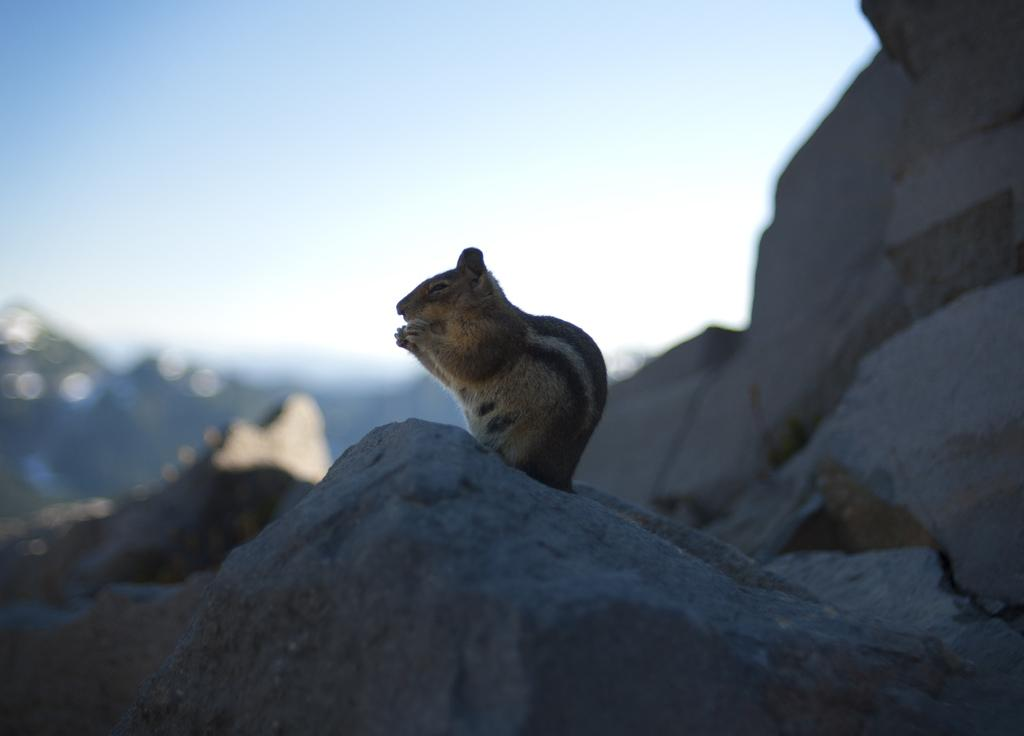What animal can be seen in the image? There is a squirrel on a rock in the image. How would you describe the background of the image? The background of the image is blurred. What part of the natural environment is visible in the image? The sky is visible in the image. What type of notebook is the squirrel holding in the image? There is no notebook present in the image; it features a squirrel on a rock with a blurred background and visible sky. 